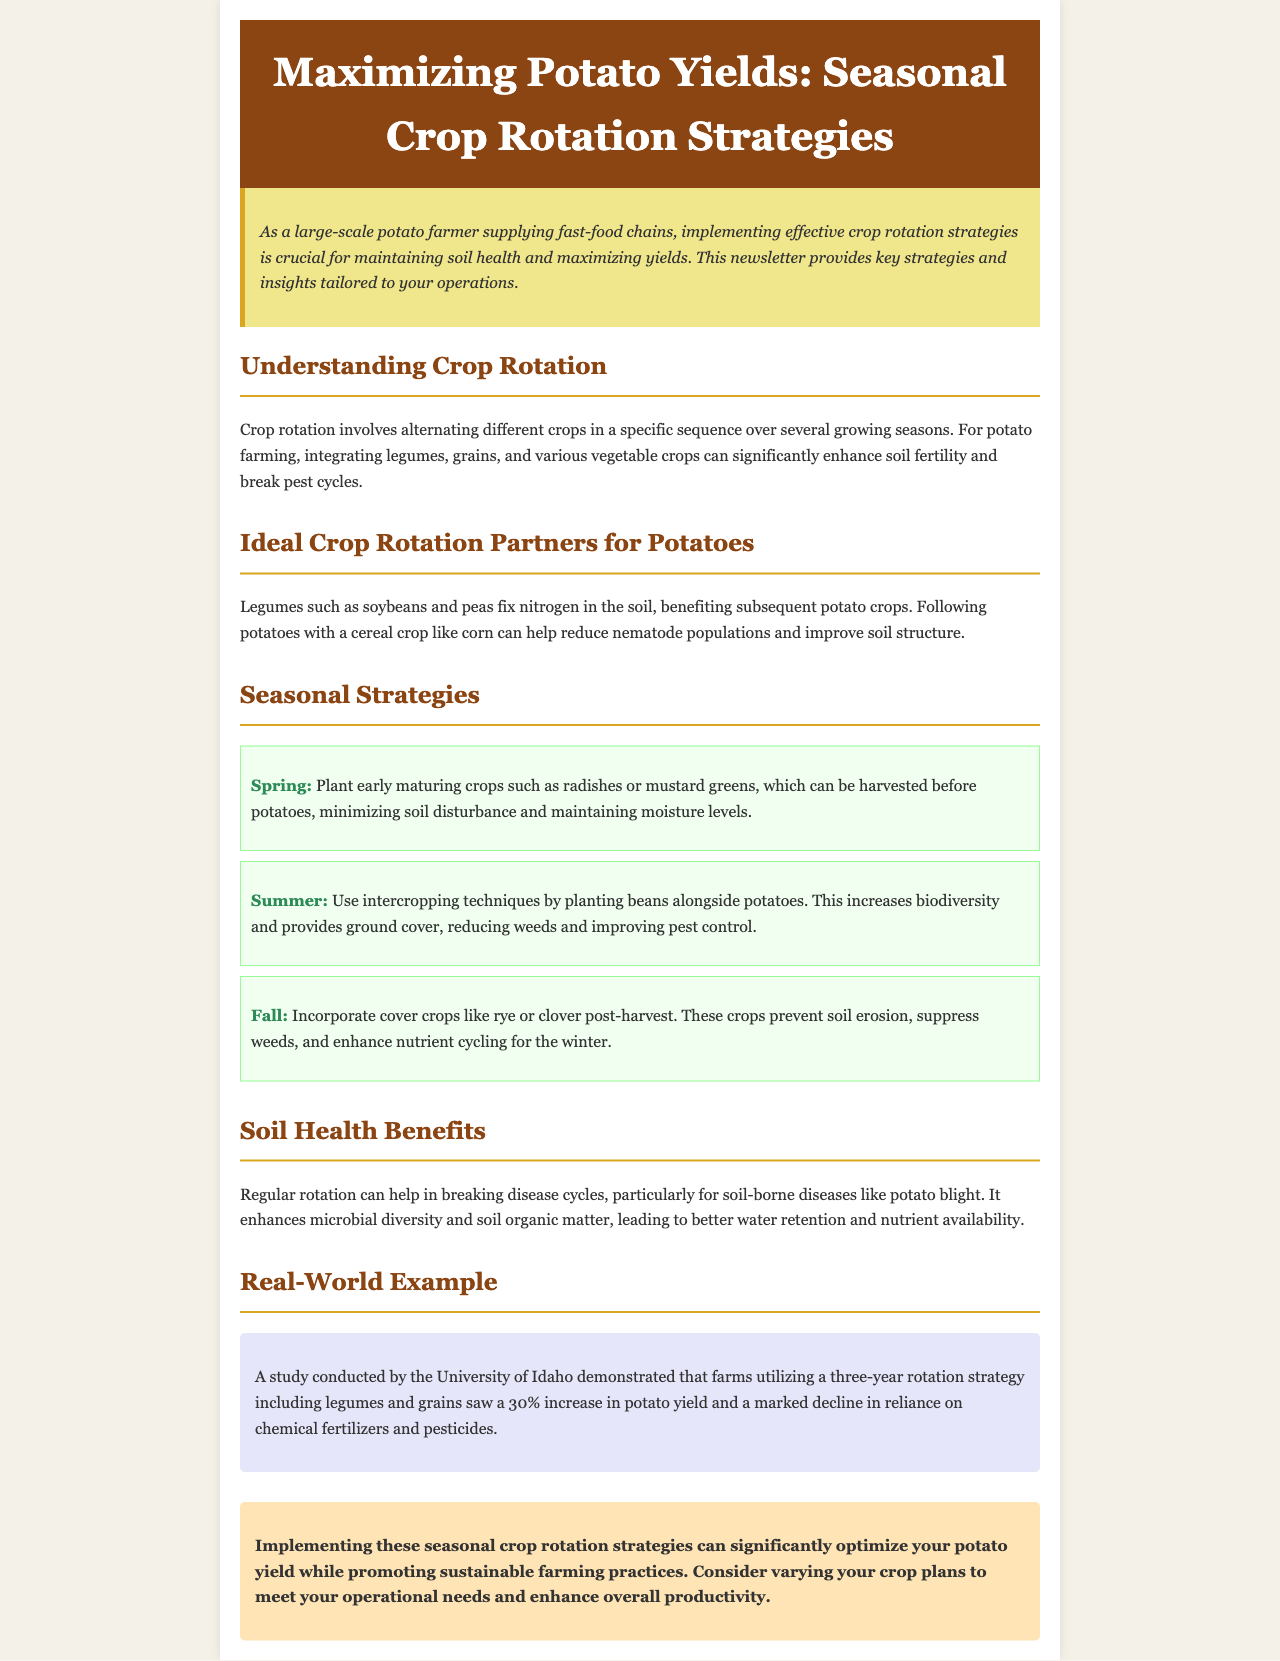What is the title of the newsletter? The title of the newsletter is found at the top of the document, which introduces the main topic.
Answer: Maximizing Potato Yields: Seasonal Crop Rotation Strategies What is the main benefit of crop rotation mentioned? The main benefit is stated in the introduction and is tied to maintaining soil health and maximizing yields.
Answer: Maintaining soil health What crop is recommended to plant in the spring? The recommendation is explicitly stated in the seasonal strategies section for spring planting.
Answer: Radishes or mustard greens What type of crops should follow potatoes in rotation? This is mentioned in the "Ideal Crop Rotation Partners for Potatoes" section regarding the following crop.
Answer: Cereal crop What should be incorporated post-harvest in the fall? The fall strategy discusses what crops to use after harvesting potatoes to improve soil conditions.
Answer: Cover crops like rye or clover What was the increase in potato yield reported in the study? The real-world example includes a specific percentage increase in potato yield due to crop rotation.
Answer: 30% How do legumes benefit potato farming? The relationship and benefits of legumes to subsequent crops are explained in the ideal partners section.
Answer: Fix nitrogen in the soil What aspect of soil health is enhanced by regular rotation? The soil health benefits section indicates a particular aspect of soil health that improves with crop rotation.
Answer: Microbial diversity What is the conclusion on implementing crop rotation strategies? The conclusion provides a summary of the overall impact of the strategies discussed earlier in the document.
Answer: Optimize potato yield 